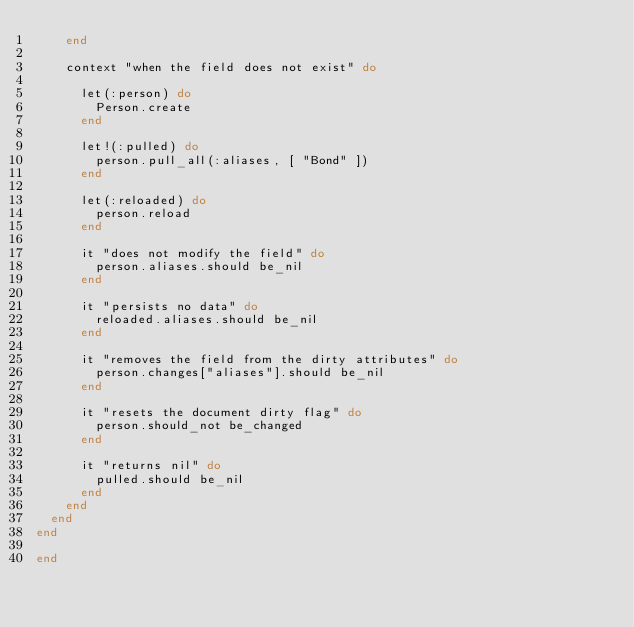Convert code to text. <code><loc_0><loc_0><loc_500><loc_500><_Ruby_>    end

    context "when the field does not exist" do

      let(:person) do
        Person.create
      end

      let!(:pulled) do
        person.pull_all(:aliases, [ "Bond" ])
      end

      let(:reloaded) do
        person.reload
      end

      it "does not modify the field" do
        person.aliases.should be_nil
      end

      it "persists no data" do
        reloaded.aliases.should be_nil
      end

      it "removes the field from the dirty attributes" do
        person.changes["aliases"].should be_nil
      end

      it "resets the document dirty flag" do
        person.should_not be_changed
      end

      it "returns nil" do
        pulled.should be_nil
      end
    end
  end
end

end
</code> 